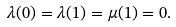<formula> <loc_0><loc_0><loc_500><loc_500>\lambda ( 0 ) = \lambda ( 1 ) = \mu ( 1 ) = 0 .</formula> 